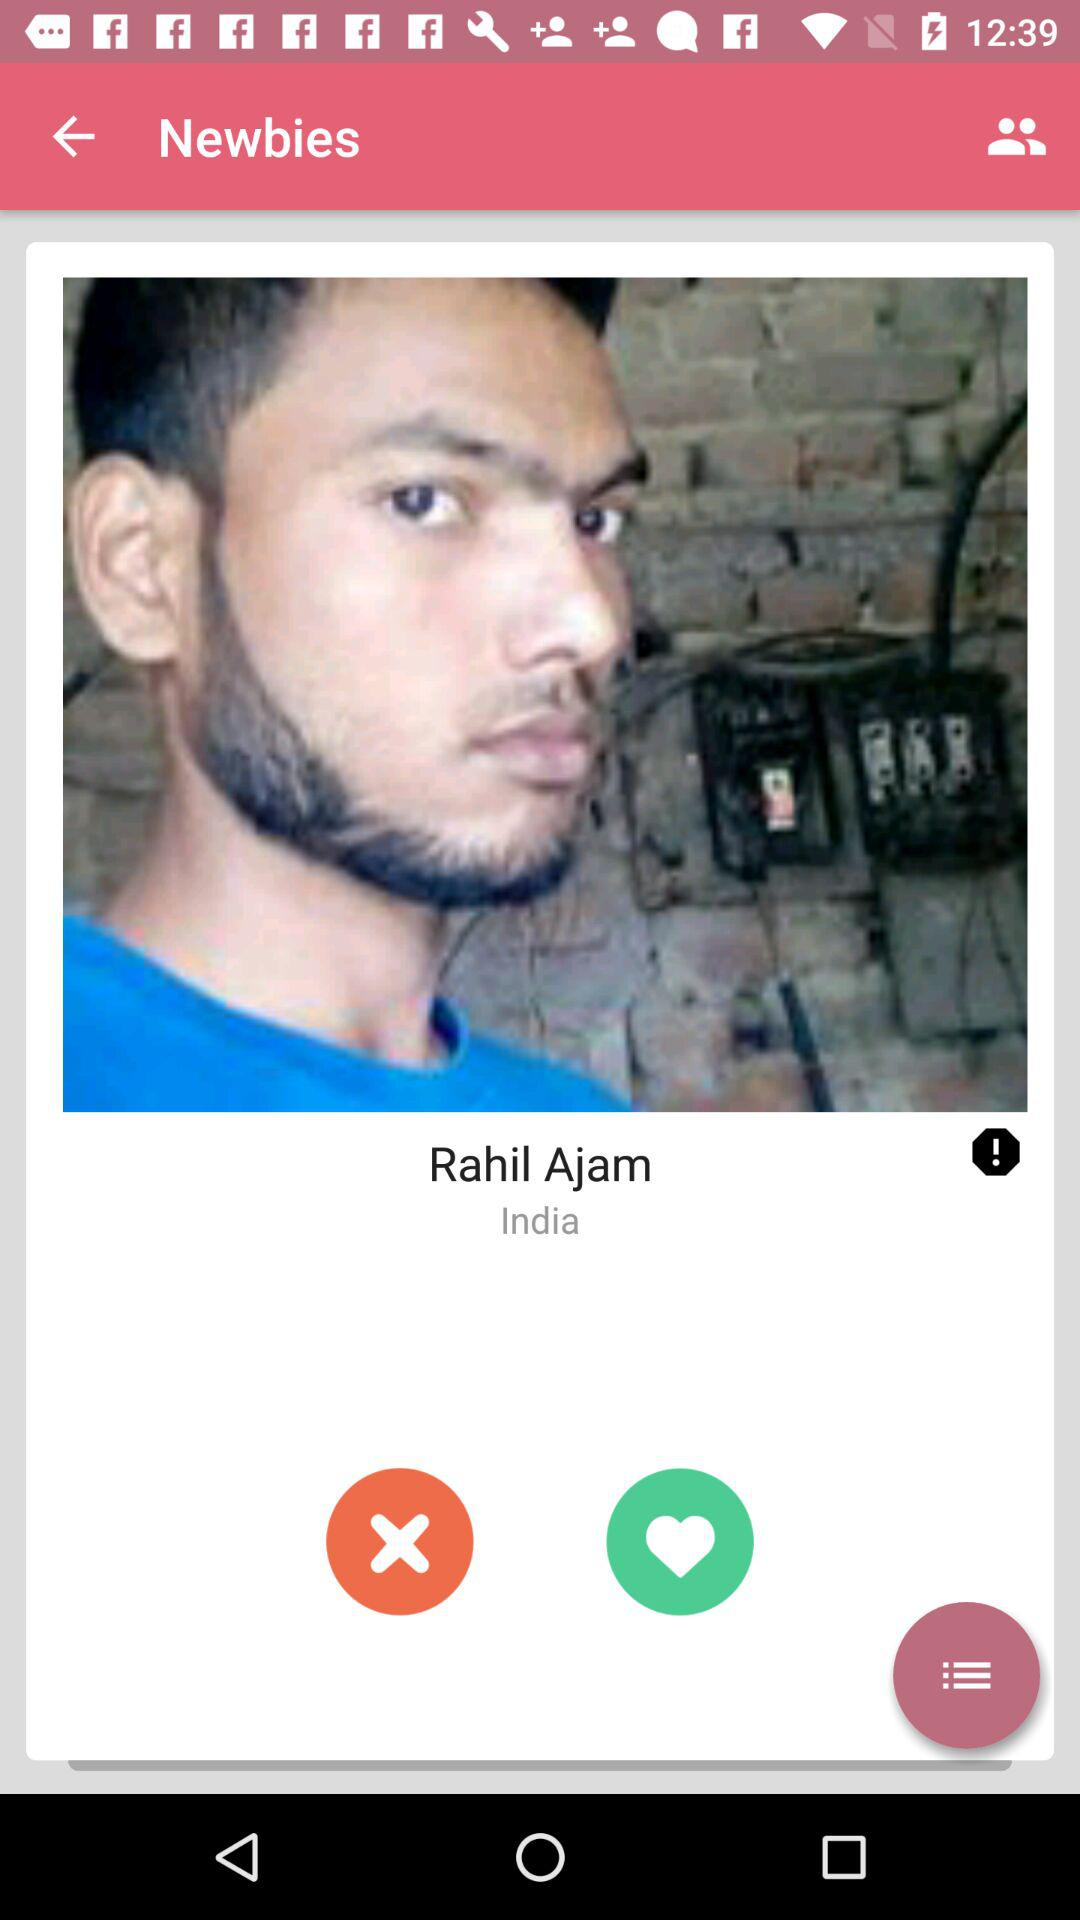What is the name of the user? The name of the user is Rahil Ajam. 